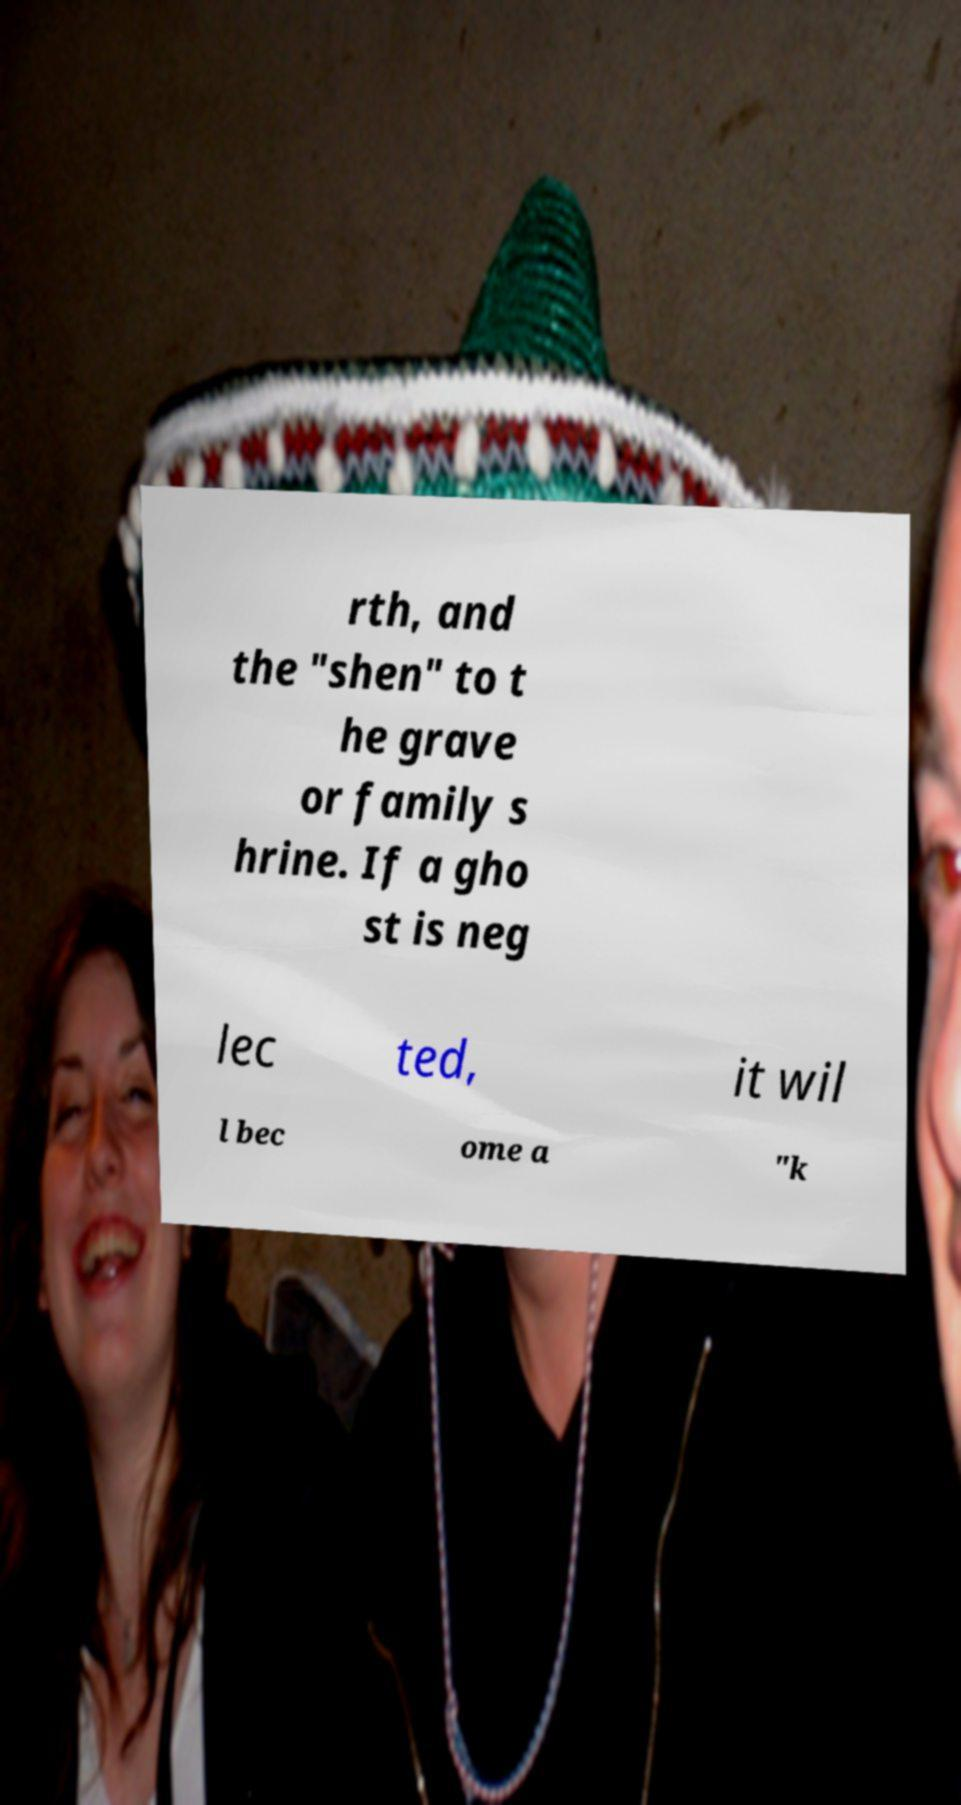Please read and relay the text visible in this image. What does it say? rth, and the "shen" to t he grave or family s hrine. If a gho st is neg lec ted, it wil l bec ome a "k 